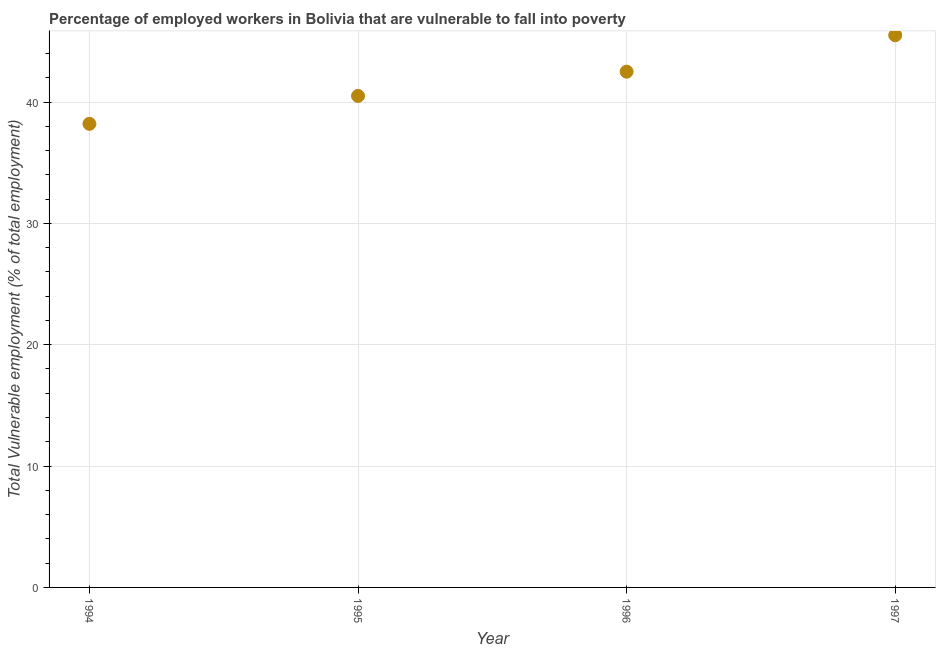What is the total vulnerable employment in 1994?
Your response must be concise. 38.2. Across all years, what is the maximum total vulnerable employment?
Your answer should be very brief. 45.5. Across all years, what is the minimum total vulnerable employment?
Give a very brief answer. 38.2. In which year was the total vulnerable employment minimum?
Your answer should be compact. 1994. What is the sum of the total vulnerable employment?
Ensure brevity in your answer.  166.7. What is the difference between the total vulnerable employment in 1995 and 1996?
Offer a terse response. -2. What is the average total vulnerable employment per year?
Give a very brief answer. 41.68. What is the median total vulnerable employment?
Offer a terse response. 41.5. What is the ratio of the total vulnerable employment in 1994 to that in 1996?
Offer a terse response. 0.9. What is the difference between the highest and the lowest total vulnerable employment?
Offer a very short reply. 7.3. How many dotlines are there?
Your answer should be very brief. 1. What is the difference between two consecutive major ticks on the Y-axis?
Keep it short and to the point. 10. Are the values on the major ticks of Y-axis written in scientific E-notation?
Offer a terse response. No. Does the graph contain any zero values?
Offer a terse response. No. Does the graph contain grids?
Offer a very short reply. Yes. What is the title of the graph?
Offer a terse response. Percentage of employed workers in Bolivia that are vulnerable to fall into poverty. What is the label or title of the Y-axis?
Provide a succinct answer. Total Vulnerable employment (% of total employment). What is the Total Vulnerable employment (% of total employment) in 1994?
Your response must be concise. 38.2. What is the Total Vulnerable employment (% of total employment) in 1995?
Make the answer very short. 40.5. What is the Total Vulnerable employment (% of total employment) in 1996?
Provide a succinct answer. 42.5. What is the Total Vulnerable employment (% of total employment) in 1997?
Your answer should be compact. 45.5. What is the difference between the Total Vulnerable employment (% of total employment) in 1994 and 1996?
Your answer should be very brief. -4.3. What is the difference between the Total Vulnerable employment (% of total employment) in 1995 and 1997?
Your response must be concise. -5. What is the ratio of the Total Vulnerable employment (% of total employment) in 1994 to that in 1995?
Provide a short and direct response. 0.94. What is the ratio of the Total Vulnerable employment (% of total employment) in 1994 to that in 1996?
Make the answer very short. 0.9. What is the ratio of the Total Vulnerable employment (% of total employment) in 1994 to that in 1997?
Keep it short and to the point. 0.84. What is the ratio of the Total Vulnerable employment (% of total employment) in 1995 to that in 1996?
Give a very brief answer. 0.95. What is the ratio of the Total Vulnerable employment (% of total employment) in 1995 to that in 1997?
Keep it short and to the point. 0.89. What is the ratio of the Total Vulnerable employment (% of total employment) in 1996 to that in 1997?
Offer a very short reply. 0.93. 